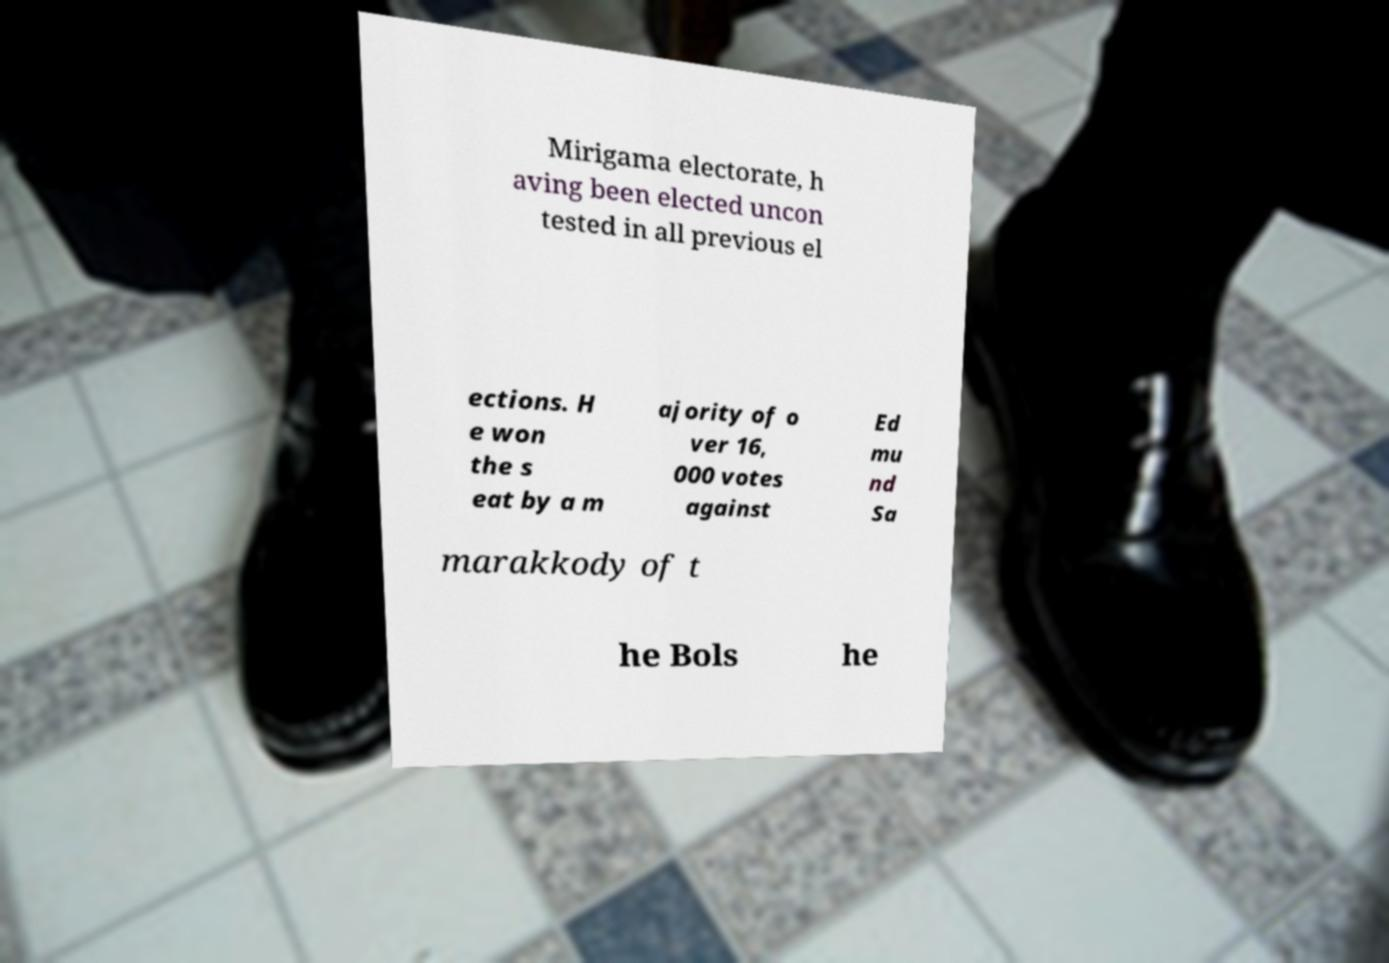There's text embedded in this image that I need extracted. Can you transcribe it verbatim? Mirigama electorate, h aving been elected uncon tested in all previous el ections. H e won the s eat by a m ajority of o ver 16, 000 votes against Ed mu nd Sa marakkody of t he Bols he 